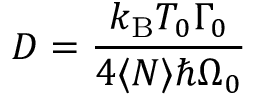Convert formula to latex. <formula><loc_0><loc_0><loc_500><loc_500>D = \frac { k _ { B } T _ { 0 } \Gamma _ { 0 } } { 4 \langle N \rangle \hbar { \Omega } _ { 0 } }</formula> 